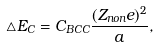<formula> <loc_0><loc_0><loc_500><loc_500>\triangle E _ { C } = C _ { B C C } \frac { ( Z _ { n o n } e ) ^ { 2 } } { a } ,</formula> 